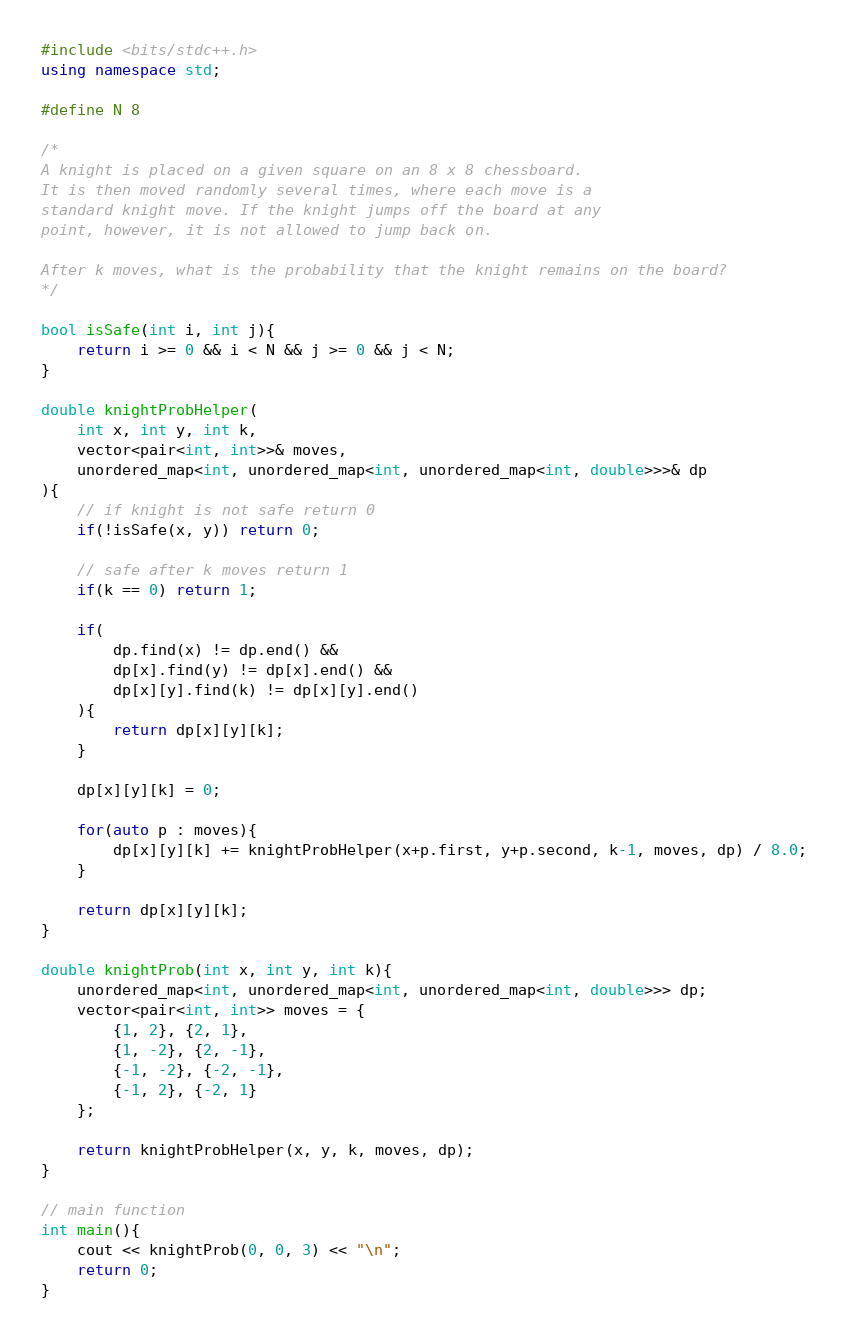<code> <loc_0><loc_0><loc_500><loc_500><_C++_>#include <bits/stdc++.h>
using namespace std;

#define N 8

/*
A knight is placed on a given square on an 8 x 8 chessboard.
It is then moved randomly several times, where each move is a
standard knight move. If the knight jumps off the board at any
point, however, it is not allowed to jump back on.

After k moves, what is the probability that the knight remains on the board?
*/

bool isSafe(int i, int j){
    return i >= 0 && i < N && j >= 0 && j < N;
}

double knightProbHelper(
    int x, int y, int k,
    vector<pair<int, int>>& moves,
    unordered_map<int, unordered_map<int, unordered_map<int, double>>>& dp
){
    // if knight is not safe return 0
    if(!isSafe(x, y)) return 0;

    // safe after k moves return 1
    if(k == 0) return 1;

    if(
        dp.find(x) != dp.end() &&
        dp[x].find(y) != dp[x].end() &&
        dp[x][y].find(k) != dp[x][y].end()
    ){
        return dp[x][y][k];
    }

    dp[x][y][k] = 0;

    for(auto p : moves){
        dp[x][y][k] += knightProbHelper(x+p.first, y+p.second, k-1, moves, dp) / 8.0;
    }

    return dp[x][y][k];
}

double knightProb(int x, int y, int k){
    unordered_map<int, unordered_map<int, unordered_map<int, double>>> dp;
    vector<pair<int, int>> moves = {
        {1, 2}, {2, 1},
        {1, -2}, {2, -1},
        {-1, -2}, {-2, -1},
        {-1, 2}, {-2, 1}
    };

    return knightProbHelper(x, y, k, moves, dp);
}

// main function
int main(){
    cout << knightProb(0, 0, 3) << "\n";
    return 0;
}</code> 